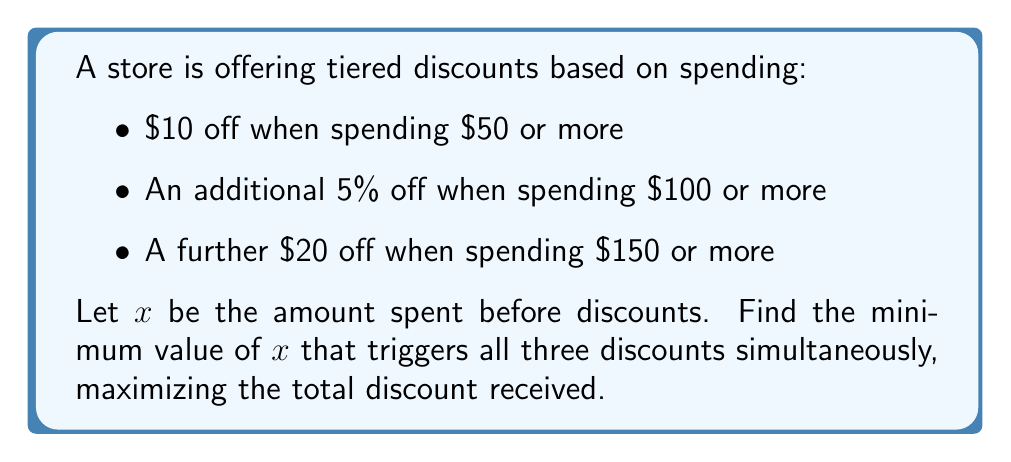Give your solution to this math problem. 1) First, we need to ensure $x \geq 150$ to trigger all three discounts.

2) The total discount will be:
   $10 + 0.05x + 20$

3) However, the 5% discount is applied after the first $10 off:
   $10 + 0.05(x-10) + 20$

4) Simplify:
   $10 + 0.05x - 0.5 + 20$
   $= 0.05x + 29.5$

5) To maximize the discount while minimizing spending, we want:
   $x - (0.05x + 29.5) = 150$

6) Solve for $x$:
   $0.95x - 120.5 = 0$
   $0.95x = 120.5$
   $x = 120.5 / 0.95 = 126.84$

7) Round up to the nearest cent:
   $x = 126.85$

8) Verify:
   Spent: $126.85
   First discount: $10
   Second discount: $0.05 * (126.85 - 10) = $5.84
   Third discount: $20
   Total discount: $35.84
   Final price: $126.85 - $35.84 = $91.01

   Indeed, $91.01 is just above the $91 threshold needed to keep all discounts active.
Answer: $126.85 